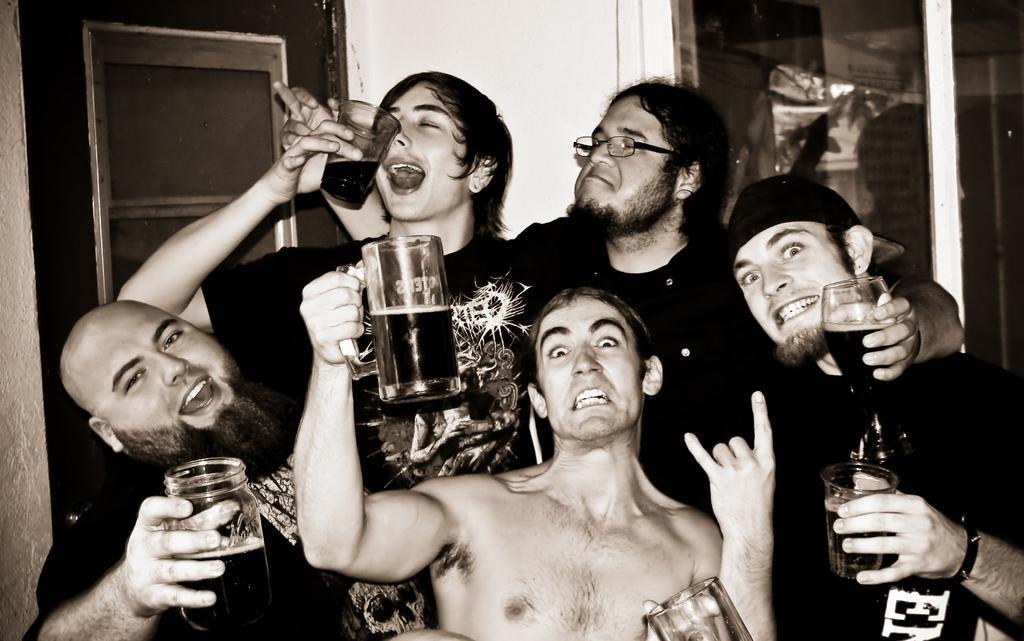In one or two sentences, can you explain what this image depicts? In this image I can see few persons. All of them are holding a glass in their hands. In the background I can see a door. 